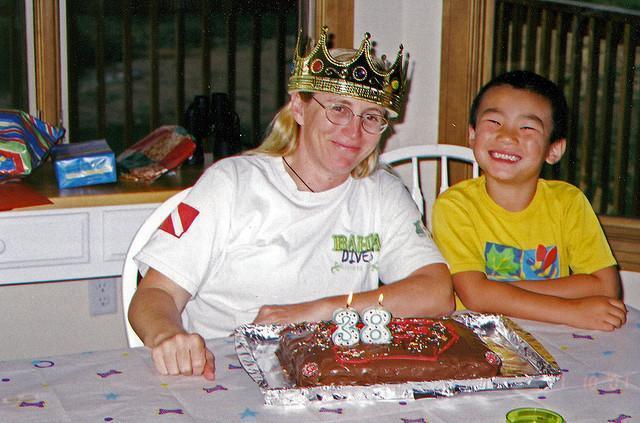How many chairs are there?
Give a very brief answer. 2. How many people are visible?
Give a very brief answer. 2. 